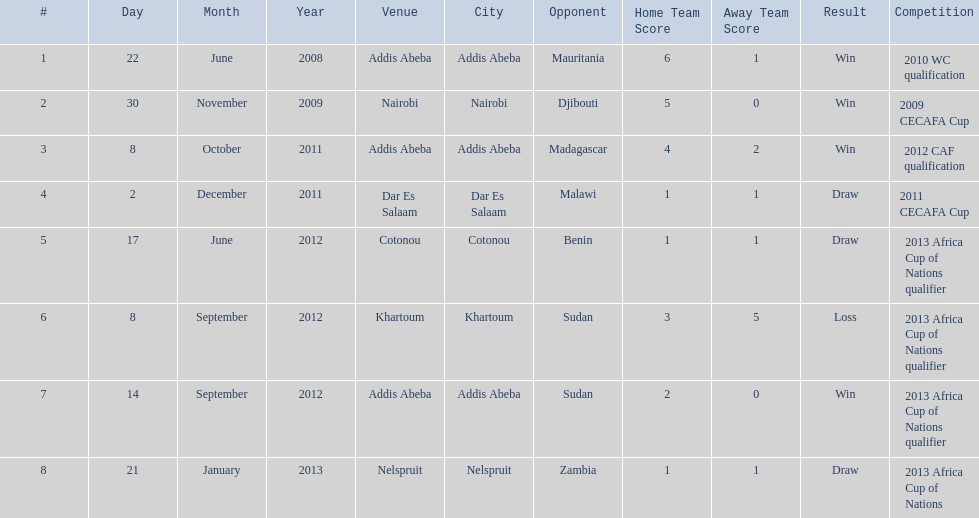True or false? in comparison, the ethiopian national team has more draws than wins. False. 